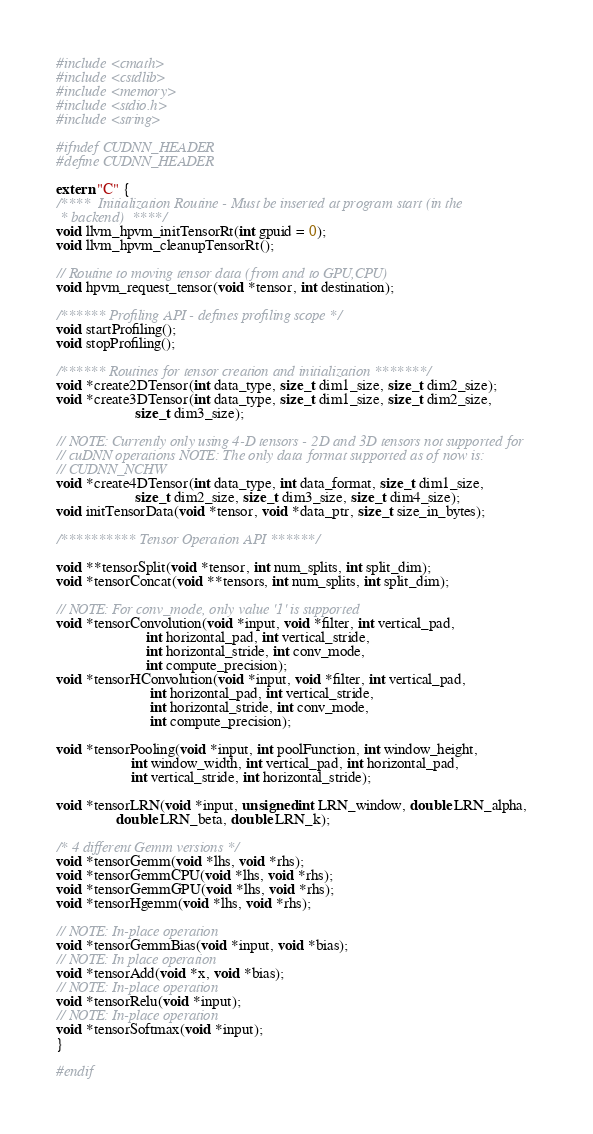<code> <loc_0><loc_0><loc_500><loc_500><_C++_>
#include <cmath>
#include <cstdlib>
#include <memory>
#include <stdio.h>
#include <string>

#ifndef CUDNN_HEADER
#define CUDNN_HEADER

extern "C" {
/****  Initialization Routine - Must be inserted at program start (in the
 * backend)  ****/
void llvm_hpvm_initTensorRt(int gpuid = 0);
void llvm_hpvm_cleanupTensorRt();

// Routine to moving tensor data (from and to GPU,CPU)
void hpvm_request_tensor(void *tensor, int destination);

/****** Profiling API - defines profiling scope */
void startProfiling();
void stopProfiling();

/****** Routines for tensor creation and initialization *******/
void *create2DTensor(int data_type, size_t dim1_size, size_t dim2_size);
void *create3DTensor(int data_type, size_t dim1_size, size_t dim2_size,
                     size_t dim3_size);

// NOTE: Currently only using 4-D tensors - 2D and 3D tensors not supported for
// cuDNN operations NOTE: The only data format supported as of now is:
// CUDNN_NCHW
void *create4DTensor(int data_type, int data_format, size_t dim1_size,
                     size_t dim2_size, size_t dim3_size, size_t dim4_size);
void initTensorData(void *tensor, void *data_ptr, size_t size_in_bytes);

/********** Tensor Operation API ******/

void **tensorSplit(void *tensor, int num_splits, int split_dim);
void *tensorConcat(void **tensors, int num_splits, int split_dim);

// NOTE: For conv_mode, only value '1' is supported
void *tensorConvolution(void *input, void *filter, int vertical_pad,
                        int horizontal_pad, int vertical_stride,
                        int horizontal_stride, int conv_mode,
                        int compute_precision);
void *tensorHConvolution(void *input, void *filter, int vertical_pad,
                         int horizontal_pad, int vertical_stride,
                         int horizontal_stride, int conv_mode,
                         int compute_precision);

void *tensorPooling(void *input, int poolFunction, int window_height,
                    int window_width, int vertical_pad, int horizontal_pad,
                    int vertical_stride, int horizontal_stride);

void *tensorLRN(void *input, unsigned int LRN_window, double LRN_alpha,
                double LRN_beta, double LRN_k);

/* 4 different Gemm versions */
void *tensorGemm(void *lhs, void *rhs);
void *tensorGemmCPU(void *lhs, void *rhs);
void *tensorGemmGPU(void *lhs, void *rhs);
void *tensorHgemm(void *lhs, void *rhs);

// NOTE: In-place operation
void *tensorGemmBias(void *input, void *bias);
// NOTE: In place operation
void *tensorAdd(void *x, void *bias);
// NOTE: In-place operation
void *tensorRelu(void *input);
// NOTE: In-place operation
void *tensorSoftmax(void *input);
}

#endif
</code> 